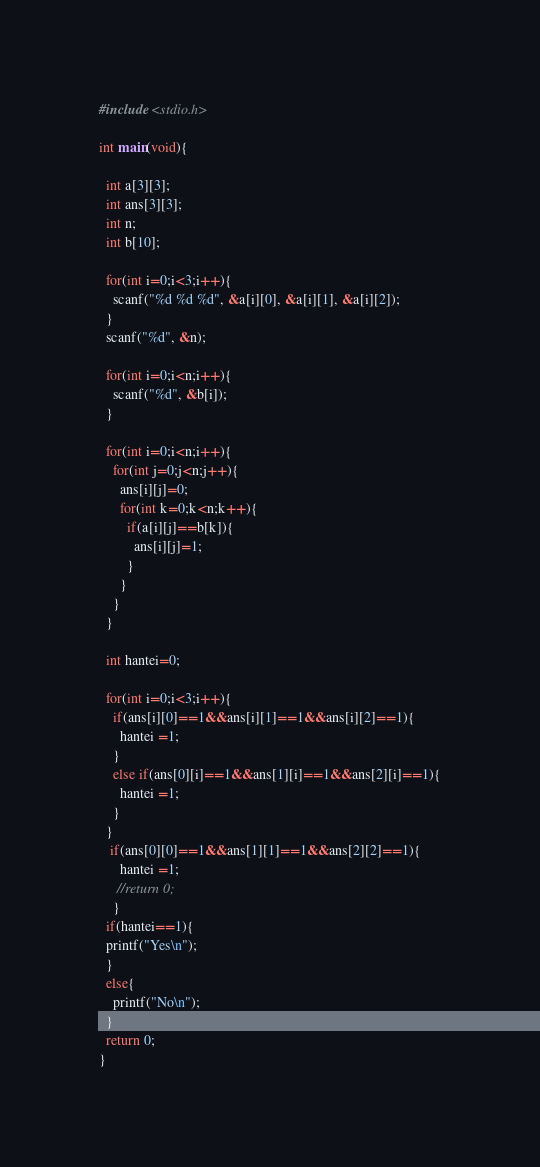Convert code to text. <code><loc_0><loc_0><loc_500><loc_500><_C_>#include <stdio.h>

int main(void){
  
  int a[3][3];
  int ans[3][3];
  int n;
  int b[10];
  
  for(int i=0;i<3;i++){
    scanf("%d %d %d", &a[i][0], &a[i][1], &a[i][2]);
  }
  scanf("%d", &n);
  
  for(int i=0;i<n;i++){
    scanf("%d", &b[i]);
  }
  
  for(int i=0;i<n;i++){
    for(int j=0;j<n;j++){
      ans[i][j]=0;
      for(int k=0;k<n;k++){
        if(a[i][j]==b[k]){
          ans[i][j]=1;
        }
      }
    }
  }
  
  int hantei=0;
  
  for(int i=0;i<3;i++){
    if(ans[i][0]==1&&ans[i][1]==1&&ans[i][2]==1){
      hantei =1;
    }
    else if(ans[0][i]==1&&ans[1][i]==1&&ans[2][i]==1){
      hantei =1;
    }
  }
   if(ans[0][0]==1&&ans[1][1]==1&&ans[2][2]==1){
      hantei =1;
     //return 0;
    }
  if(hantei==1){
  printf("Yes\n");
  }
  else{
    printf("No\n");
  }
  return 0;
}
</code> 